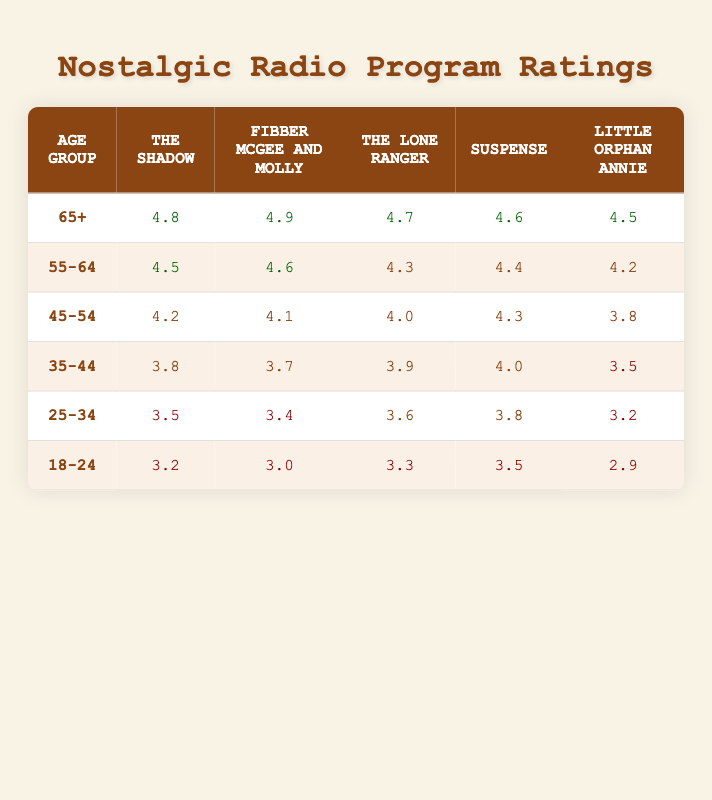What is the highest rating for "Fibber McGee and Molly" from any age group? The highest rating for "Fibber McGee and Molly" is found in the age group 65+, which has a rating of 4.9.
Answer: 4.9 What is the average rating for "The Shadow" across all age groups? To find the average rating for "The Shadow", we sum the ratings: 4.8 + 4.5 + 4.2 + 3.8 + 3.5 + 3.2 = 24.0. There are 6 age groups, so we divide by 6, resulting in an average of 24.0 / 6 = 4.0.
Answer: 4.0 Do age groups 25-34 and 18-24 have the same rating for "Little Orphan Annie"? The rating for "Little Orphan Annie" in the age group 25-34 is 3.2 and in the 18-24 group is 2.9. Since these values are not equal, the answer is no.
Answer: No Which program has the lowest rating in the 35-44 age group? In the 35-44 age group, the ratings for the programs are: The Shadow 3.8, Fibber McGee and Molly 3.7, The Lone Ranger 3.9, Suspense 4.0, and Little Orphan Annie 3.5. The lowest rating here is for "Little Orphan Annie" with a rating of 3.5.
Answer: Little Orphan Annie Which age group has a rating of 4.2 for "Fibber McGee and Molly"? Looking at the ratings for "Fibber McGee and Molly", the age group 55-64 has a rating of 4.6, while the 45-54 age group has a rating of 4.1. Therefore, none of the groups list a 4.2 rating for "Fibber McGee and Molly".
Answer: None 